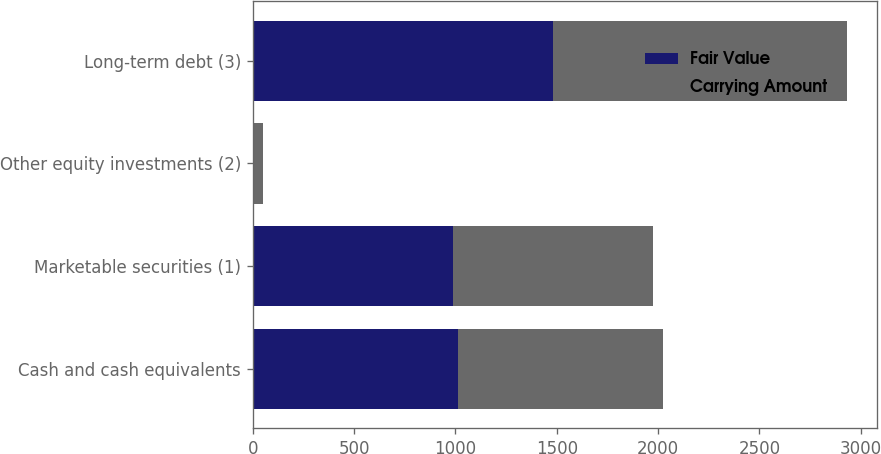<chart> <loc_0><loc_0><loc_500><loc_500><stacked_bar_chart><ecel><fcel>Cash and cash equivalents<fcel>Marketable securities (1)<fcel>Other equity investments (2)<fcel>Long-term debt (3)<nl><fcel>Fair Value<fcel>1013<fcel>987<fcel>8<fcel>1480<nl><fcel>Carrying Amount<fcel>1013<fcel>987<fcel>45<fcel>1454<nl></chart> 